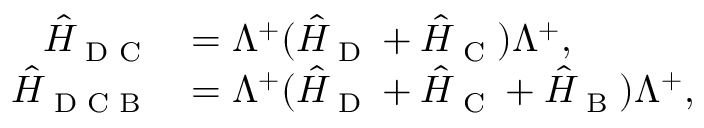Convert formula to latex. <formula><loc_0><loc_0><loc_500><loc_500>\begin{array} { r l } { \hat { H } _ { D C } } & { = \Lambda ^ { + } ( \hat { H } _ { D } + \hat { H } _ { C } ) \Lambda ^ { + } , } \\ { \hat { H } _ { D C B } } & { = \Lambda ^ { + } ( \hat { H } _ { D } + \hat { H } _ { C } + \hat { H } _ { B } ) \Lambda ^ { + } , } \end{array}</formula> 